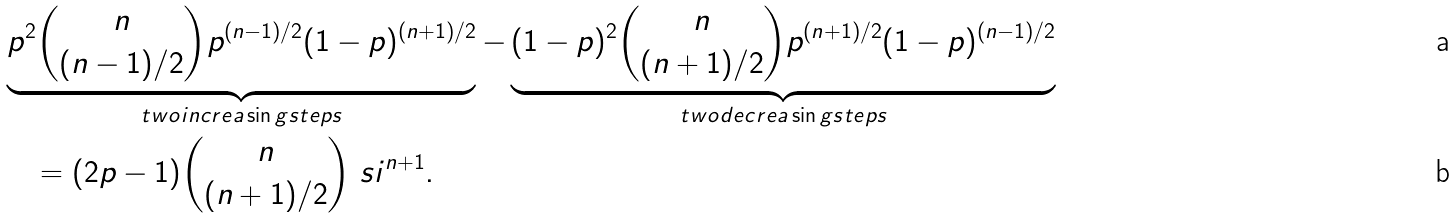Convert formula to latex. <formula><loc_0><loc_0><loc_500><loc_500>& \underbrace { p ^ { 2 } \binom { n } { ( n - 1 ) / 2 } p ^ { ( n - 1 ) / 2 } ( 1 - p ) ^ { ( n + 1 ) / 2 } } _ { t w o i n c r e a \sin g s t e p s } - \underbrace { ( 1 - p ) ^ { 2 } \binom { n } { ( n + 1 ) / 2 } p ^ { ( n + 1 ) / 2 } ( 1 - p ) ^ { ( n - 1 ) / 2 } } _ { t w o d e c r e a \sin g s t e p s } \\ & \quad = ( 2 p - 1 ) \binom { n } { ( n + 1 ) / 2 } \ s i ^ { n + 1 } .</formula> 